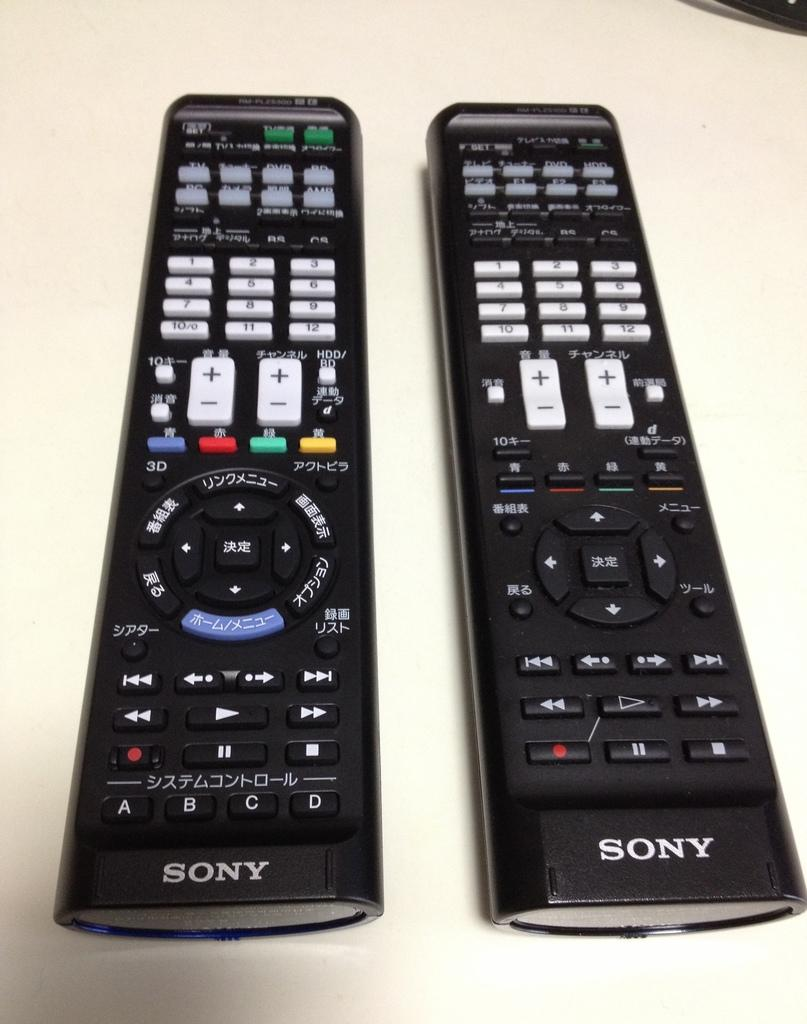Provide a one-sentence caption for the provided image. Two Sony remote controls, one with Asian writing, sit side by side. 